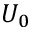Convert formula to latex. <formula><loc_0><loc_0><loc_500><loc_500>U _ { 0 }</formula> 